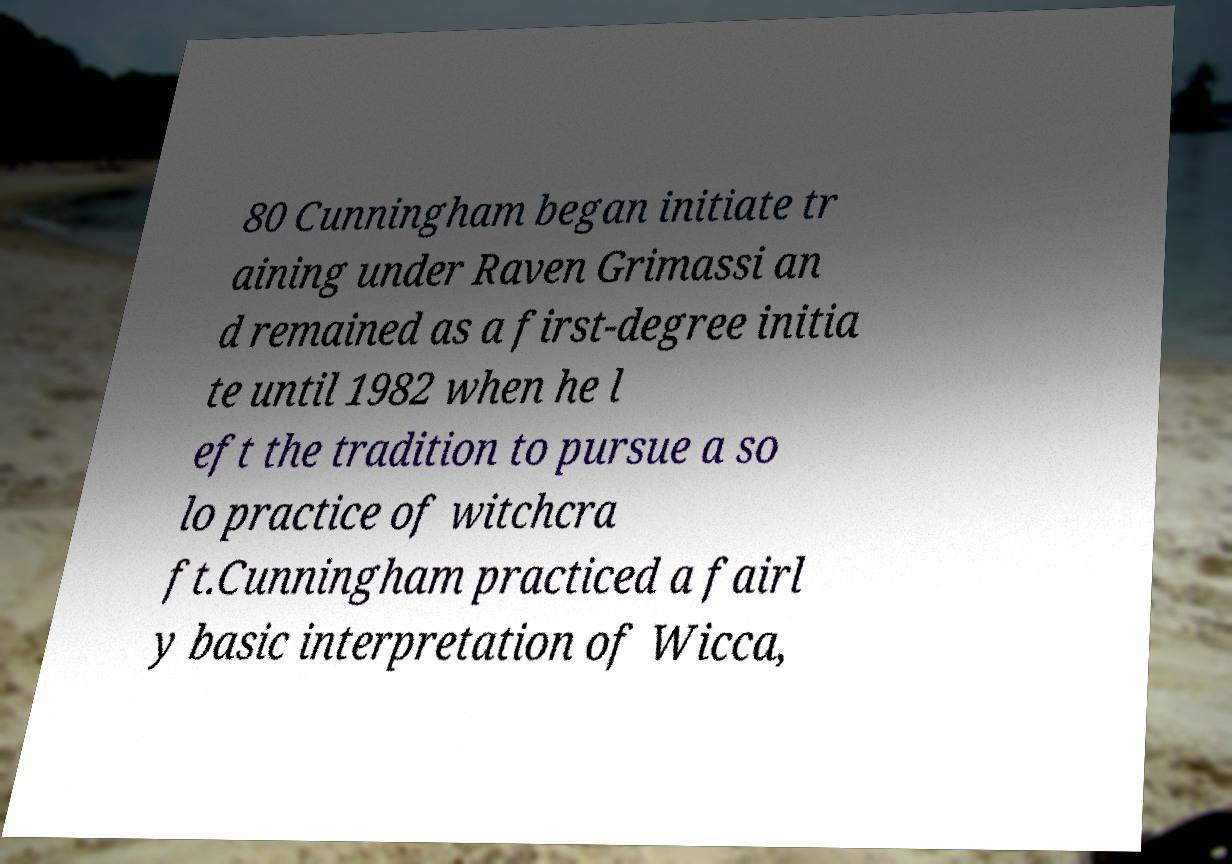Could you extract and type out the text from this image? 80 Cunningham began initiate tr aining under Raven Grimassi an d remained as a first-degree initia te until 1982 when he l eft the tradition to pursue a so lo practice of witchcra ft.Cunningham practiced a fairl y basic interpretation of Wicca, 